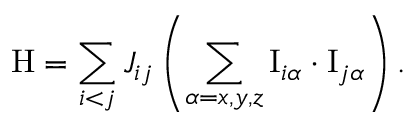Convert formula to latex. <formula><loc_0><loc_0><loc_500><loc_500>H = \sum _ { i < j } J _ { i j } \left ( \sum _ { \alpha = x , y , z } I _ { i \alpha } \cdot I _ { j \alpha } \right ) .</formula> 